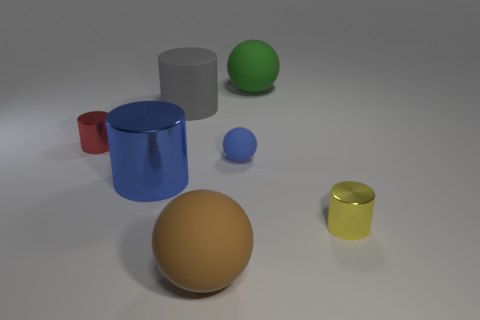What material is the large blue thing that is the same shape as the yellow metal thing?
Make the answer very short. Metal. The big matte cylinder is what color?
Make the answer very short. Gray. What number of other things are the same color as the big metallic cylinder?
Your response must be concise. 1. How many things are tiny metal objects that are right of the big blue cylinder or blue metallic cylinders?
Your answer should be very brief. 2. There is a small shiny thing on the left side of the matte sphere that is behind the tiny cylinder on the left side of the big green thing; what is its shape?
Ensure brevity in your answer.  Cylinder. What number of tiny metal objects are the same shape as the blue matte object?
Your response must be concise. 0. What material is the ball that is the same color as the large shiny cylinder?
Give a very brief answer. Rubber. Are the large green object and the blue ball made of the same material?
Offer a terse response. Yes. What number of small yellow cylinders are behind the cylinder that is behind the red cylinder in front of the big gray matte cylinder?
Keep it short and to the point. 0. Are there any yellow things made of the same material as the large green object?
Provide a succinct answer. No. 